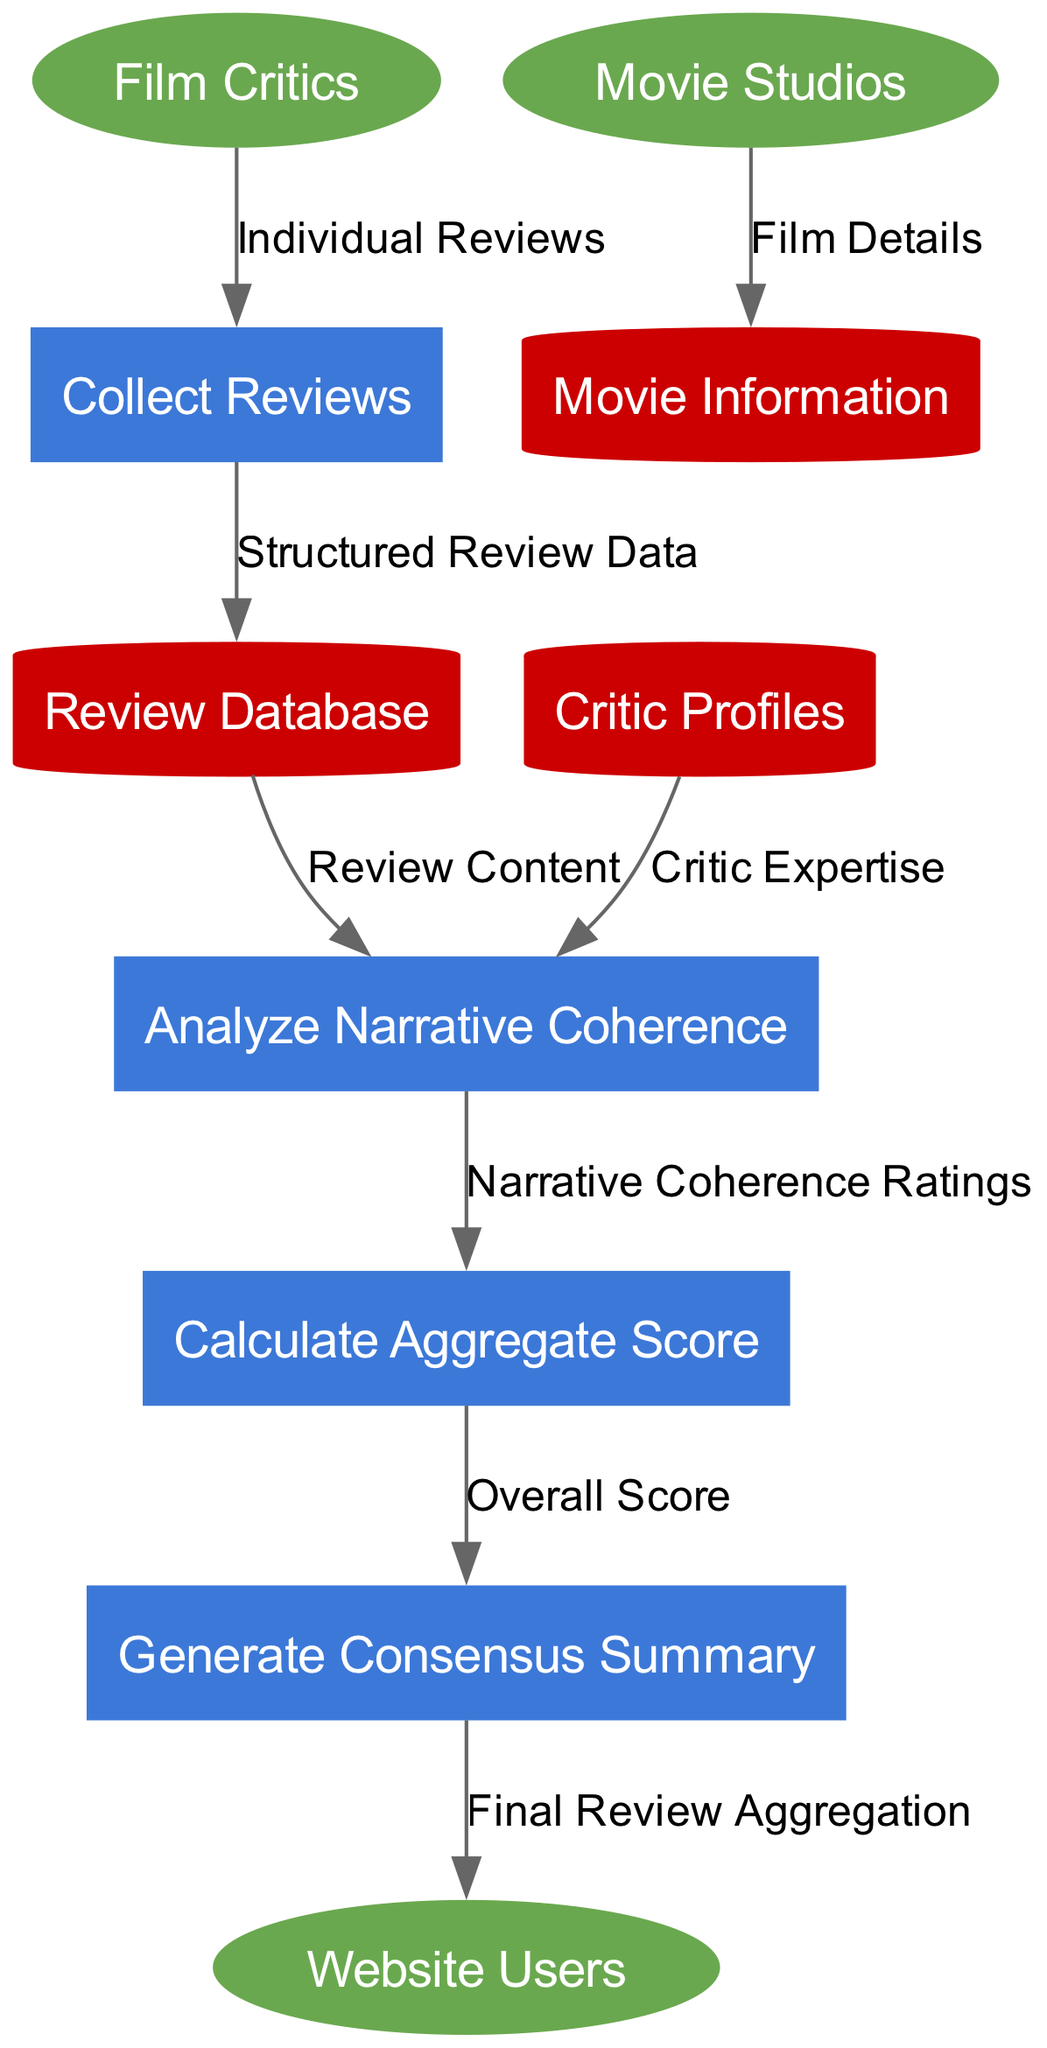What is the total number of external entities in the diagram? The diagram has three external entities: Film Critics, Movie Studios, and Website Users. Therefore, adding them gives a total of 3 external entities.
Answer: 3 Which process is responsible for analyzing narrative coherence? The process labeled "Analyze Narrative Coherence" is specifically designed to evaluate the coherence of reviews received. It directly handles the narrative aspects from the inputs it receives.
Answer: Analyze Narrative Coherence How many data stores are represented in the diagram? The diagram features three data stores: Review Database, Critic Profiles, and Movie Information. Counting these gives us a total of 3 data stores.
Answer: 3 What data flow connects Film Critics to the review database? The flow from Film Critics to Collect Reviews is labeled "Individual Reviews," which in turn feeds into the Review Database as "Structured Review Data." Thus, the connection is through Collect Reviews first.
Answer: Individual Reviews What is the final output directed towards Website Users? The diagram indicates that the final output being sent to Website Users is labeled "Final Review Aggregation," which summarizes the aggregated reviews for the audience.
Answer: Final Review Aggregation Which process receives both review content and critic expertise? The "Analyze Narrative Coherence" process receives inputs from both the Review Database (through "Review Content") and Critic Profiles (through "Critic Expertise"). This means it uses these two data flows for analysis.
Answer: Analyze Narrative Coherence What type of entity is "Review Database"? In the diagram, "Review Database" is classified as a data store, indicated by its rectangular shape with a cylindrical representation, distinguishing it from processes or external entities.
Answer: Data Store How does the narrative coherence ratings influence the aggregation process? The "Narrative Coherence Ratings" flow from "Analyze Narrative Coherence" is utilized by "Calculate Aggregate Score" to determine the overall score for the reviews. This helps in generating a comprehensive evaluation based on coherence.
Answer: Overall Score What role do Movie Studios have in the diagram? Movie Studios contribute film details to the "Movie Information" data store, which is critical for the aggregation process as it contextualizes the reviews being analyzed.
Answer: Film Details 